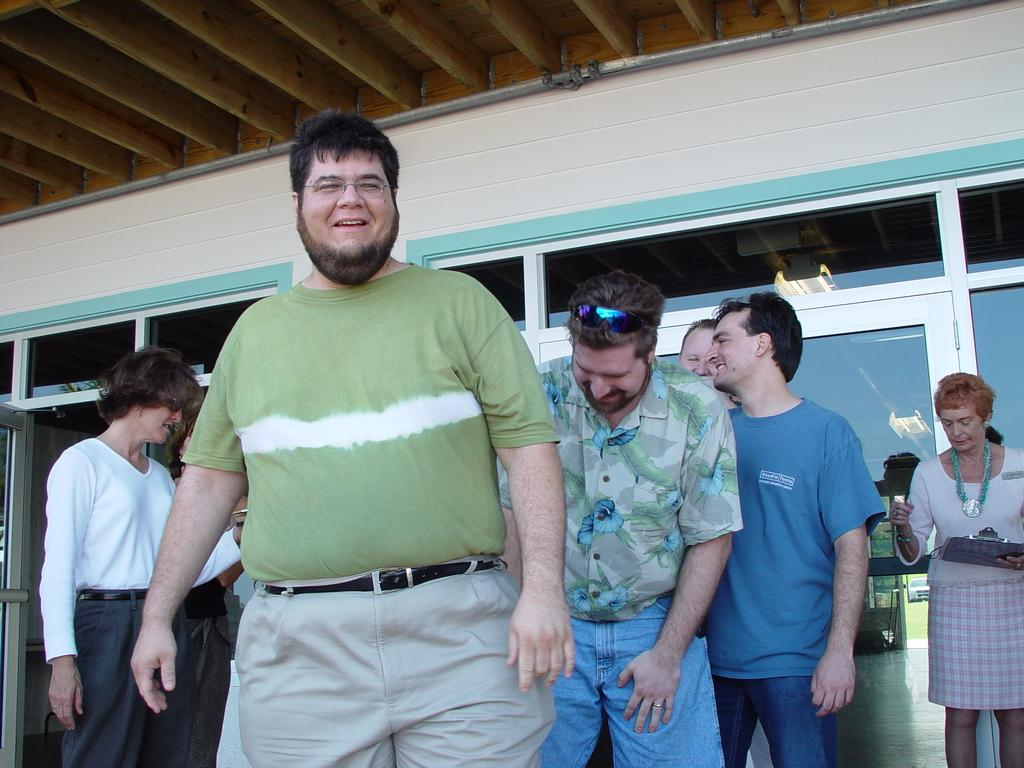What is happening in the image? There are people standing in the image. Can you describe what the woman on the right side is holding? The woman is holding a pad on the right side. What can be seen in the background of the image? There is glass visible in the background. How does the wind affect the people in the image? There is no wind present in the image, so its effect cannot be determined. 